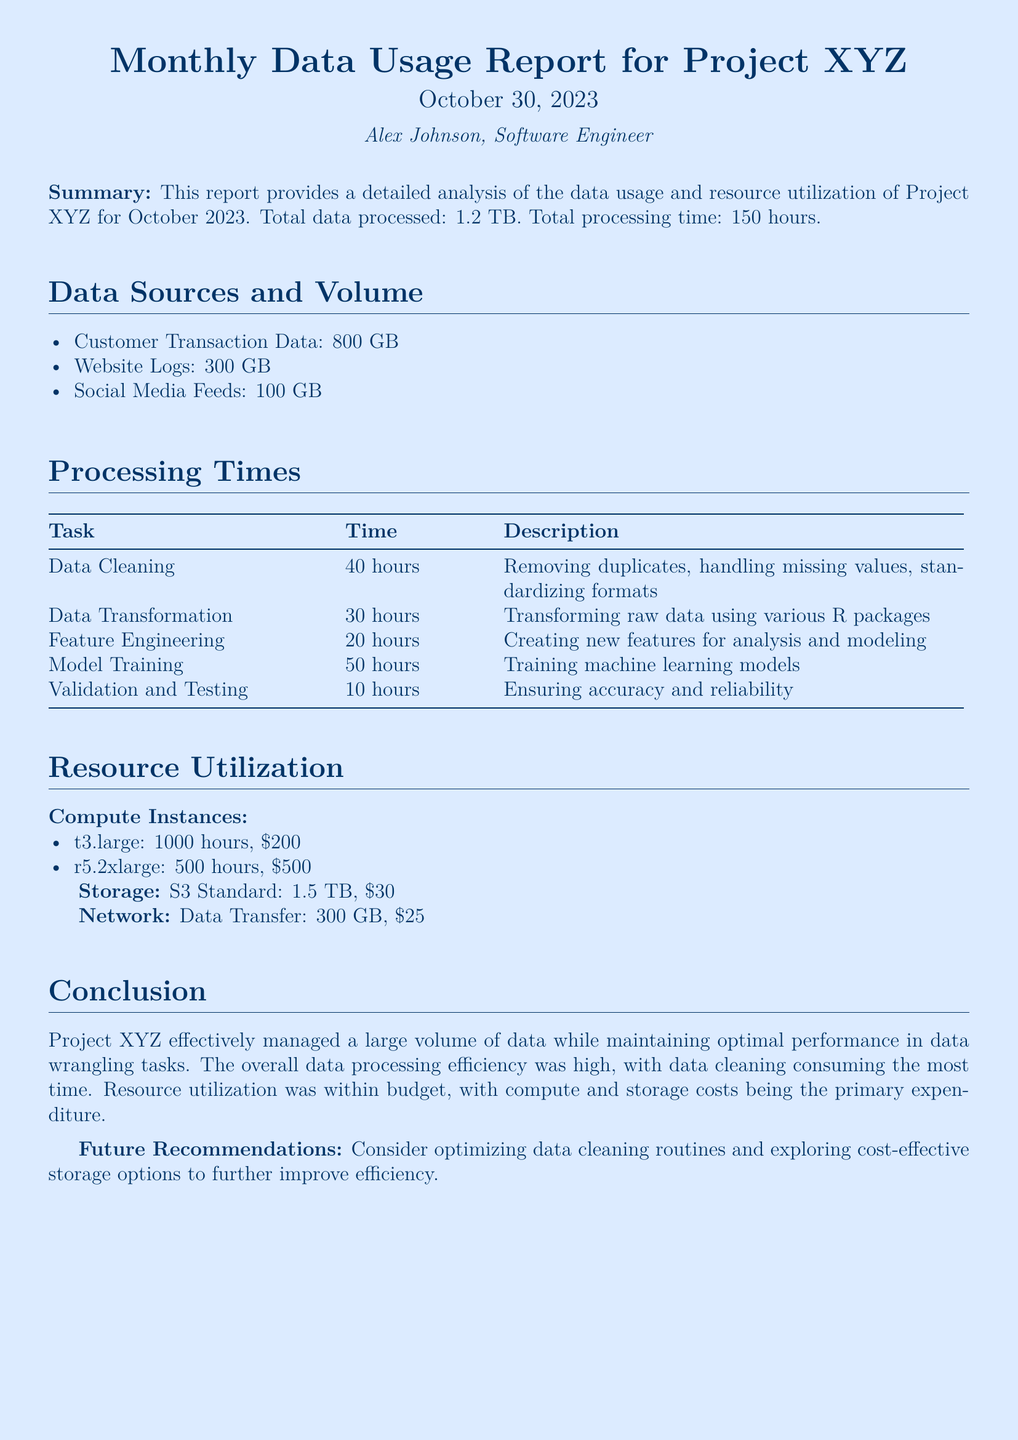What is the total data processed? The total data processed is explicitly stated in the report as 1.2 TB.
Answer: 1.2 TB Who is the author of the report? The author is mentioned in the introduction of the document as Alex Johnson.
Answer: Alex Johnson How many hours were spent on data cleaning? The document lists the time spent on data cleaning as 40 hours under the Processing Times section.
Answer: 40 hours What is the cost of the r5.2xlarge instance? The cost of the r5.2xlarge instance is provided in the Resource Utilization section as $500.
Answer: $500 Which data source had the largest volume? The largest data source mentioned in the Data Sources and Volume section is Customer Transaction Data, with a volume of 800 GB.
Answer: Customer Transaction Data What is the total processing time for all tasks? The report specifies that the total processing time is 150 hours, which is the sum of all task times listed.
Answer: 150 hours What is one recommendation for future improvement? The conclusion presents a recommendation to consider optimizing data cleaning routines.
Answer: Optimizing data cleaning routines How many hours were dedicated to model training? The specific time allotted for model training is noted as 50 hours in the Processing Times section.
Answer: 50 hours 